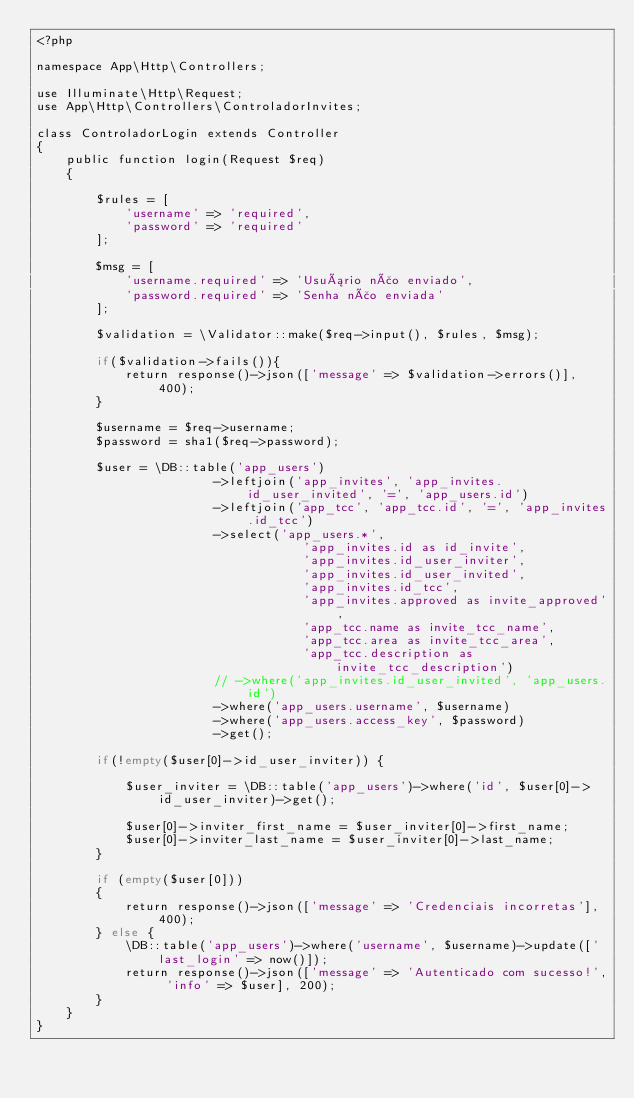Convert code to text. <code><loc_0><loc_0><loc_500><loc_500><_PHP_><?php

namespace App\Http\Controllers;

use Illuminate\Http\Request;
use App\Http\Controllers\ControladorInvites;

class ControladorLogin extends Controller
{
    public function login(Request $req)
    {

        $rules = [
            'username' => 'required',
            'password' => 'required'
        ];

        $msg = [ 
            'username.required' => 'Usuário não enviado',
            'password.required' => 'Senha não enviada'
        ];

        $validation = \Validator::make($req->input(), $rules, $msg);

        if($validation->fails()){
            return response()->json(['message' => $validation->errors()], 400);
        }

        $username = $req->username;
        $password = sha1($req->password);

        $user = \DB::table('app_users')
                        ->leftjoin('app_invites', 'app_invites.id_user_invited', '=', 'app_users.id')
                        ->leftjoin('app_tcc', 'app_tcc.id', '=', 'app_invites.id_tcc')
                        ->select('app_users.*', 
                                    'app_invites.id as id_invite', 
                                    'app_invites.id_user_inviter',
                                    'app_invites.id_user_invited',
                                    'app_invites.id_tcc', 
                                    'app_invites.approved as invite_approved', 
                                    'app_tcc.name as invite_tcc_name', 
                                    'app_tcc.area as invite_tcc_area', 
                                    'app_tcc.description as invite_tcc_description')
                        // ->where('app_invites.id_user_invited', 'app_users.id')
                        ->where('app_users.username', $username)
                        ->where('app_users.access_key', $password)
                        ->get();

        if(!empty($user[0]->id_user_inviter)) {

            $user_inviter = \DB::table('app_users')->where('id', $user[0]->id_user_inviter)->get();

            $user[0]->inviter_first_name = $user_inviter[0]->first_name;
            $user[0]->inviter_last_name = $user_inviter[0]->last_name;
        }

        if (empty($user[0]))
        {
            return response()->json(['message' => 'Credenciais incorretas'], 400);
        } else {
            \DB::table('app_users')->where('username', $username)->update(['last_login' => now()]);
            return response()->json(['message' => 'Autenticado com sucesso!', 'info' => $user], 200);
        }
    }
}
</code> 